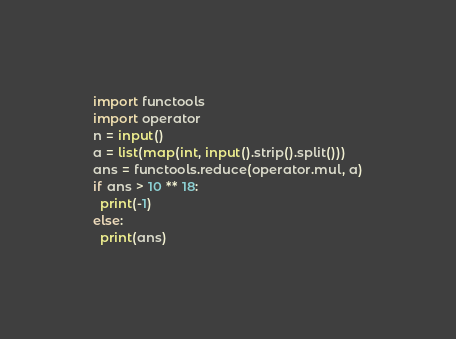<code> <loc_0><loc_0><loc_500><loc_500><_Python_>import functools
import operator
n = input()
a = list(map(int, input().strip().split()))
ans = functools.reduce(operator.mul, a)
if ans > 10 ** 18:
  print(-1)
else:
  print(ans)</code> 